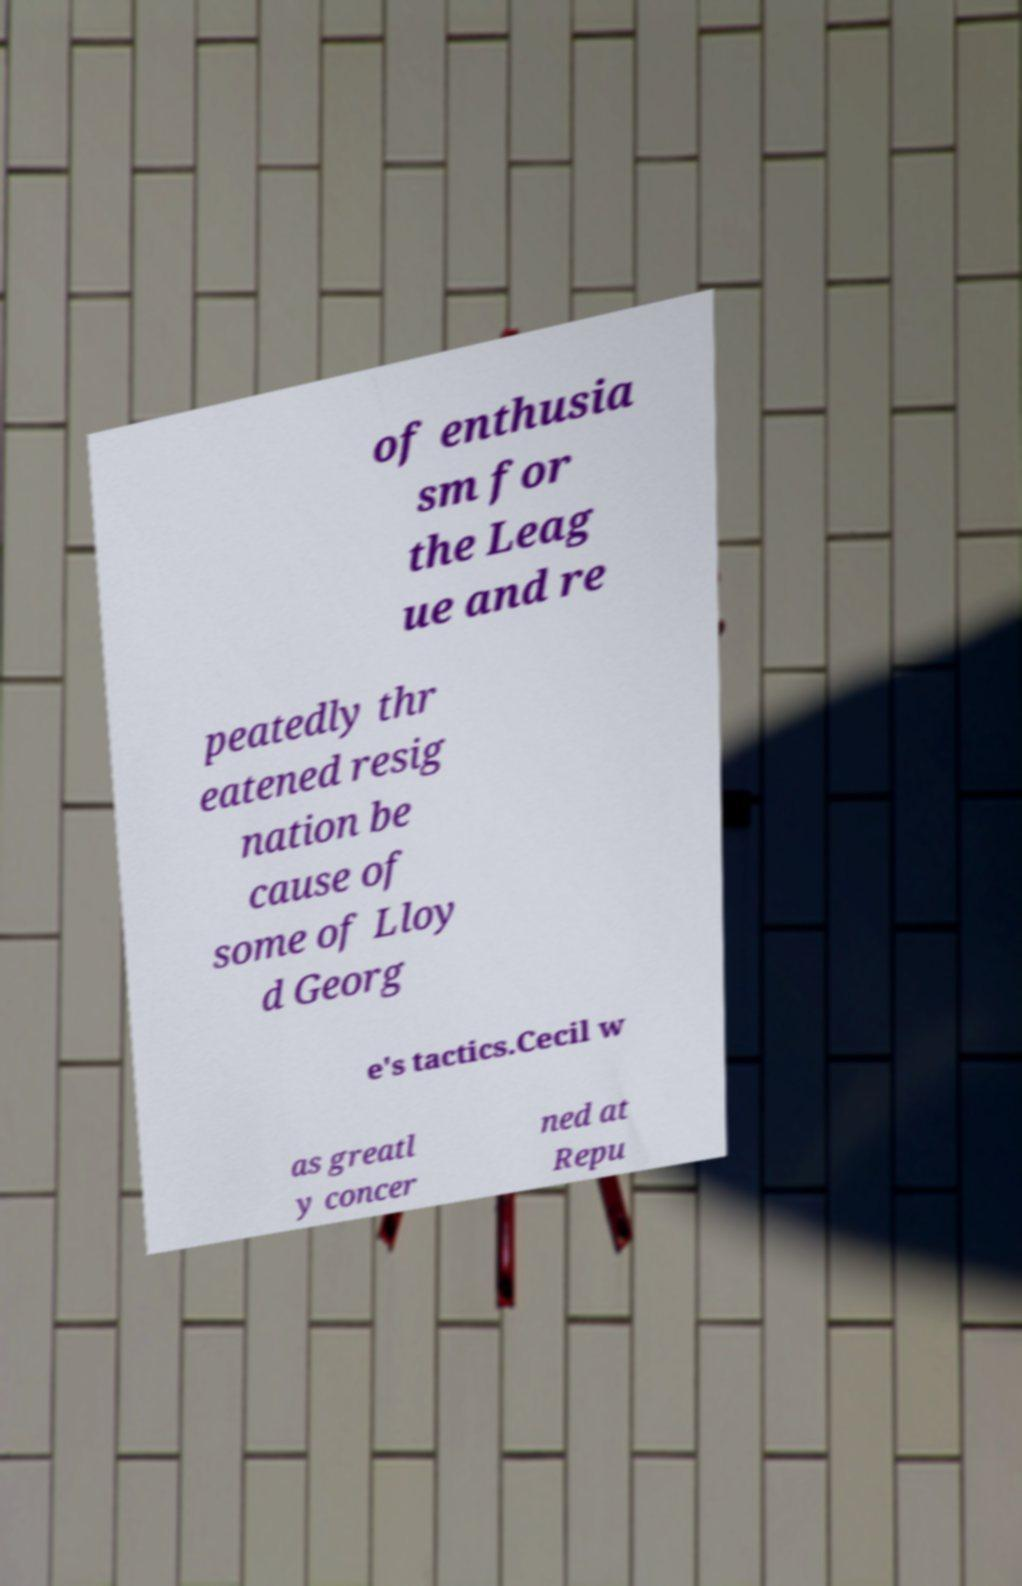What messages or text are displayed in this image? I need them in a readable, typed format. of enthusia sm for the Leag ue and re peatedly thr eatened resig nation be cause of some of Lloy d Georg e's tactics.Cecil w as greatl y concer ned at Repu 